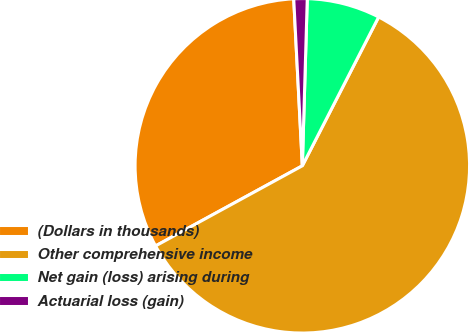Convert chart to OTSL. <chart><loc_0><loc_0><loc_500><loc_500><pie_chart><fcel>(Dollars in thousands)<fcel>Other comprehensive income<fcel>Net gain (loss) arising during<fcel>Actuarial loss (gain)<nl><fcel>32.13%<fcel>59.5%<fcel>7.07%<fcel>1.29%<nl></chart> 